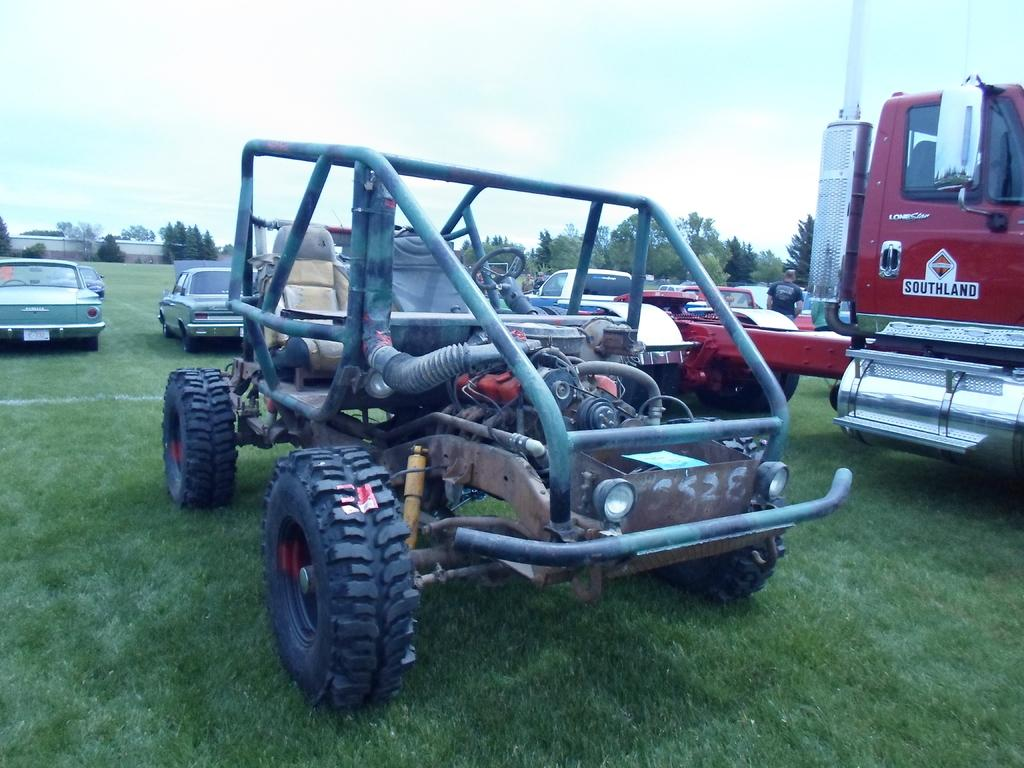What is located on the grass in the image? There are vehicles on the grass in the image. What can be seen on the right side of the image? There is a steel object on the right side of the image. What is visible in the background of the image? There are trees and a compound wall in the background of the image. How would you describe the sky in the image? The sky is cloudy in the image. What type of team is playing with the toy in the image? There is no team or toy present in the image. Can you describe the zipper on the steel object in the image? There is no zipper on the steel object in the image; it is a solid steel object. 